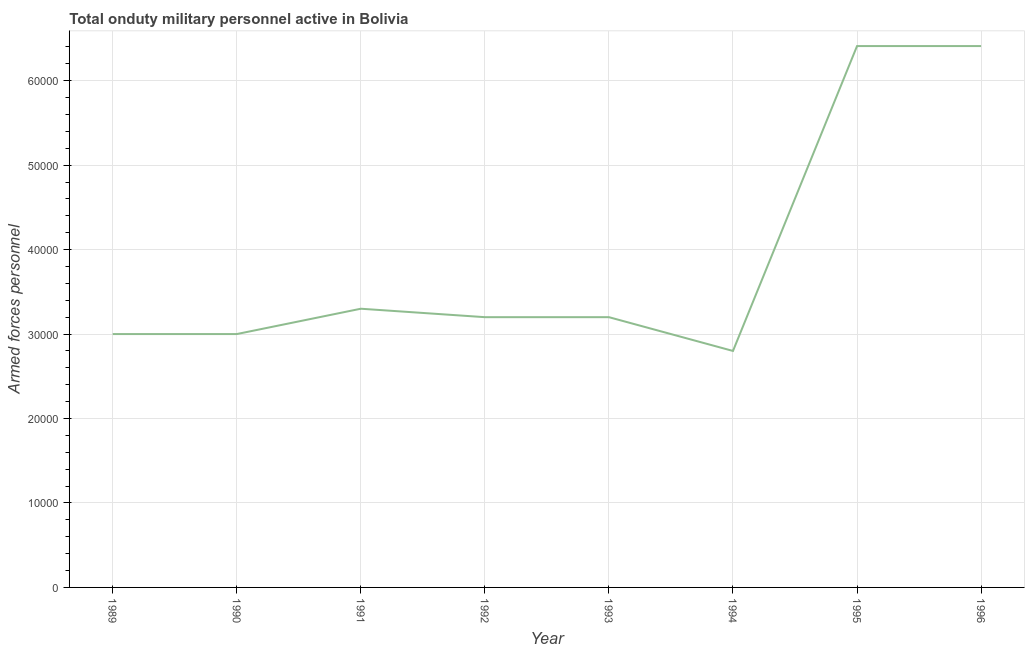What is the number of armed forces personnel in 1992?
Provide a succinct answer. 3.20e+04. Across all years, what is the maximum number of armed forces personnel?
Offer a very short reply. 6.41e+04. Across all years, what is the minimum number of armed forces personnel?
Offer a terse response. 2.80e+04. In which year was the number of armed forces personnel minimum?
Offer a very short reply. 1994. What is the sum of the number of armed forces personnel?
Make the answer very short. 3.13e+05. What is the difference between the number of armed forces personnel in 1989 and 1994?
Offer a very short reply. 2000. What is the average number of armed forces personnel per year?
Your answer should be compact. 3.92e+04. What is the median number of armed forces personnel?
Keep it short and to the point. 3.20e+04. In how many years, is the number of armed forces personnel greater than 20000 ?
Offer a very short reply. 8. What is the ratio of the number of armed forces personnel in 1991 to that in 1992?
Your response must be concise. 1.03. Is the number of armed forces personnel in 1992 less than that in 1994?
Your answer should be very brief. No. Is the difference between the number of armed forces personnel in 1989 and 1994 greater than the difference between any two years?
Provide a succinct answer. No. What is the difference between the highest and the second highest number of armed forces personnel?
Make the answer very short. 0. What is the difference between the highest and the lowest number of armed forces personnel?
Make the answer very short. 3.61e+04. How many lines are there?
Keep it short and to the point. 1. What is the title of the graph?
Offer a very short reply. Total onduty military personnel active in Bolivia. What is the label or title of the X-axis?
Provide a succinct answer. Year. What is the label or title of the Y-axis?
Keep it short and to the point. Armed forces personnel. What is the Armed forces personnel in 1989?
Provide a short and direct response. 3.00e+04. What is the Armed forces personnel in 1990?
Provide a short and direct response. 3.00e+04. What is the Armed forces personnel of 1991?
Offer a very short reply. 3.30e+04. What is the Armed forces personnel of 1992?
Provide a short and direct response. 3.20e+04. What is the Armed forces personnel in 1993?
Provide a short and direct response. 3.20e+04. What is the Armed forces personnel in 1994?
Provide a short and direct response. 2.80e+04. What is the Armed forces personnel in 1995?
Provide a short and direct response. 6.41e+04. What is the Armed forces personnel in 1996?
Give a very brief answer. 6.41e+04. What is the difference between the Armed forces personnel in 1989 and 1991?
Offer a terse response. -3000. What is the difference between the Armed forces personnel in 1989 and 1992?
Provide a succinct answer. -2000. What is the difference between the Armed forces personnel in 1989 and 1993?
Make the answer very short. -2000. What is the difference between the Armed forces personnel in 1989 and 1995?
Offer a very short reply. -3.41e+04. What is the difference between the Armed forces personnel in 1989 and 1996?
Offer a terse response. -3.41e+04. What is the difference between the Armed forces personnel in 1990 and 1991?
Your answer should be very brief. -3000. What is the difference between the Armed forces personnel in 1990 and 1992?
Provide a succinct answer. -2000. What is the difference between the Armed forces personnel in 1990 and 1993?
Offer a terse response. -2000. What is the difference between the Armed forces personnel in 1990 and 1995?
Your answer should be compact. -3.41e+04. What is the difference between the Armed forces personnel in 1990 and 1996?
Your answer should be very brief. -3.41e+04. What is the difference between the Armed forces personnel in 1991 and 1993?
Give a very brief answer. 1000. What is the difference between the Armed forces personnel in 1991 and 1995?
Offer a terse response. -3.11e+04. What is the difference between the Armed forces personnel in 1991 and 1996?
Offer a very short reply. -3.11e+04. What is the difference between the Armed forces personnel in 1992 and 1994?
Your answer should be very brief. 4000. What is the difference between the Armed forces personnel in 1992 and 1995?
Your response must be concise. -3.21e+04. What is the difference between the Armed forces personnel in 1992 and 1996?
Keep it short and to the point. -3.21e+04. What is the difference between the Armed forces personnel in 1993 and 1994?
Ensure brevity in your answer.  4000. What is the difference between the Armed forces personnel in 1993 and 1995?
Your answer should be very brief. -3.21e+04. What is the difference between the Armed forces personnel in 1993 and 1996?
Your answer should be compact. -3.21e+04. What is the difference between the Armed forces personnel in 1994 and 1995?
Keep it short and to the point. -3.61e+04. What is the difference between the Armed forces personnel in 1994 and 1996?
Keep it short and to the point. -3.61e+04. What is the difference between the Armed forces personnel in 1995 and 1996?
Your answer should be compact. 0. What is the ratio of the Armed forces personnel in 1989 to that in 1991?
Keep it short and to the point. 0.91. What is the ratio of the Armed forces personnel in 1989 to that in 1992?
Ensure brevity in your answer.  0.94. What is the ratio of the Armed forces personnel in 1989 to that in 1993?
Your answer should be compact. 0.94. What is the ratio of the Armed forces personnel in 1989 to that in 1994?
Your response must be concise. 1.07. What is the ratio of the Armed forces personnel in 1989 to that in 1995?
Give a very brief answer. 0.47. What is the ratio of the Armed forces personnel in 1989 to that in 1996?
Keep it short and to the point. 0.47. What is the ratio of the Armed forces personnel in 1990 to that in 1991?
Keep it short and to the point. 0.91. What is the ratio of the Armed forces personnel in 1990 to that in 1992?
Give a very brief answer. 0.94. What is the ratio of the Armed forces personnel in 1990 to that in 1993?
Offer a terse response. 0.94. What is the ratio of the Armed forces personnel in 1990 to that in 1994?
Offer a terse response. 1.07. What is the ratio of the Armed forces personnel in 1990 to that in 1995?
Provide a succinct answer. 0.47. What is the ratio of the Armed forces personnel in 1990 to that in 1996?
Your response must be concise. 0.47. What is the ratio of the Armed forces personnel in 1991 to that in 1992?
Provide a succinct answer. 1.03. What is the ratio of the Armed forces personnel in 1991 to that in 1993?
Your answer should be compact. 1.03. What is the ratio of the Armed forces personnel in 1991 to that in 1994?
Keep it short and to the point. 1.18. What is the ratio of the Armed forces personnel in 1991 to that in 1995?
Provide a short and direct response. 0.52. What is the ratio of the Armed forces personnel in 1991 to that in 1996?
Keep it short and to the point. 0.52. What is the ratio of the Armed forces personnel in 1992 to that in 1993?
Offer a very short reply. 1. What is the ratio of the Armed forces personnel in 1992 to that in 1994?
Keep it short and to the point. 1.14. What is the ratio of the Armed forces personnel in 1992 to that in 1995?
Provide a short and direct response. 0.5. What is the ratio of the Armed forces personnel in 1992 to that in 1996?
Your answer should be very brief. 0.5. What is the ratio of the Armed forces personnel in 1993 to that in 1994?
Your response must be concise. 1.14. What is the ratio of the Armed forces personnel in 1993 to that in 1995?
Provide a short and direct response. 0.5. What is the ratio of the Armed forces personnel in 1993 to that in 1996?
Ensure brevity in your answer.  0.5. What is the ratio of the Armed forces personnel in 1994 to that in 1995?
Your answer should be very brief. 0.44. What is the ratio of the Armed forces personnel in 1994 to that in 1996?
Offer a very short reply. 0.44. 